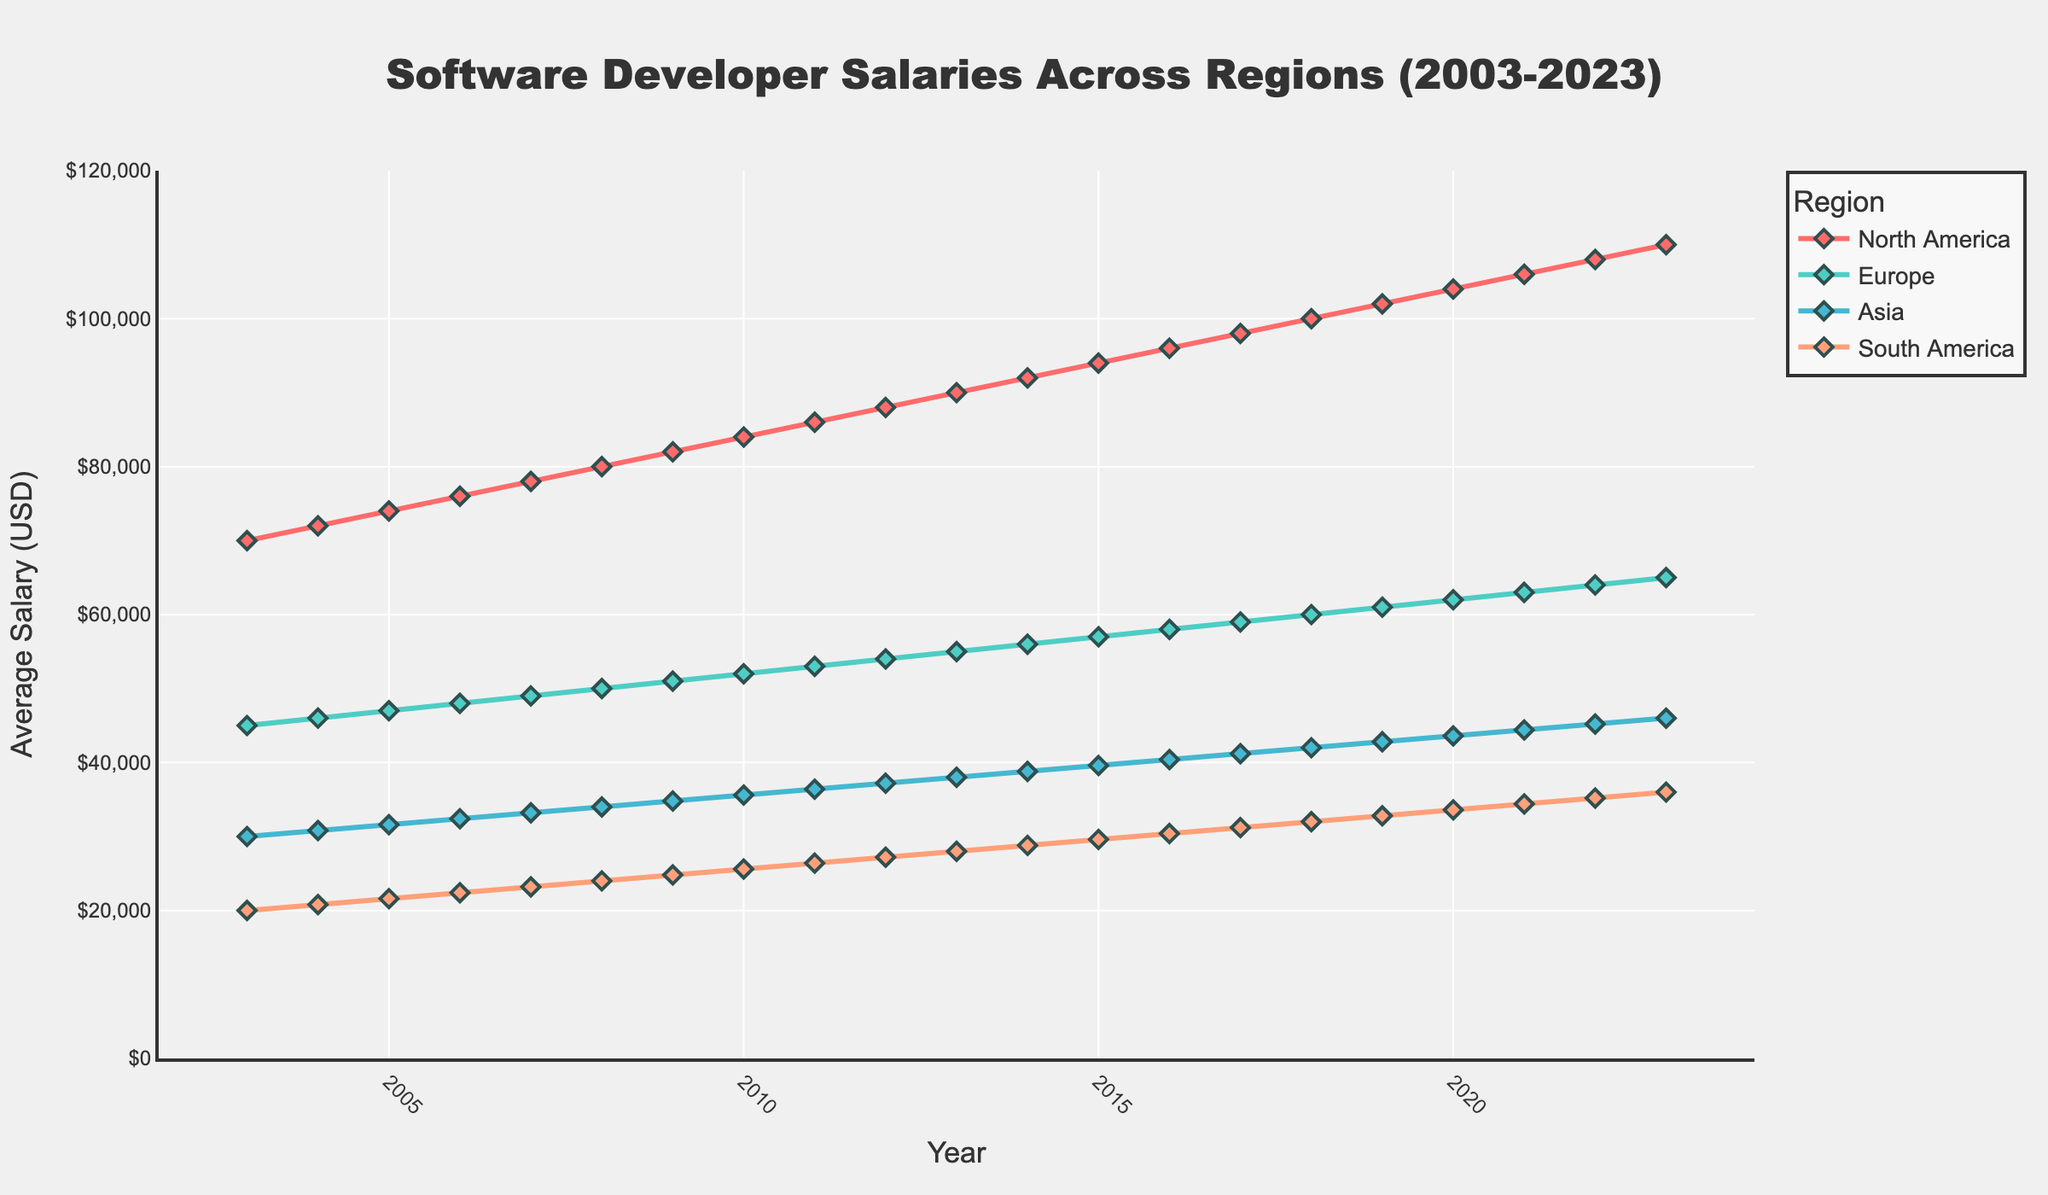What is the title of the plot? The title of the plot is displayed at the top and describes the overall content of the graph. It reads "Software Developer Salaries Across Regions (2003-2023)".
Answer: Software Developer Salaries Across Regions (2003-2023) How many regions are compared in the plot? There are four different colored lines in the plot, each representing a region. These regions are listed in the legend: North America, Europe, Asia, and South America.
Answer: 4 Which region had the highest average salary in 2023? By observing the lines' endpoints at the year 2023 on the x-axis, the North America region has the highest endpoint on the y-axis (average salary).
Answer: North America What was the average salary of software developers in Europe in 2015? By locating the year 2015 on the x-axis and following it vertically to the Europe region's line (noted by its color and legend), the approximate y-axis value is around 57,000 USD.
Answer: 57,000 USD Which region had the most significant increase in average salary over the 20 years? By comparing the starting and ending points of each region's line, North America's line shows the largest vertical increase from roughly 70,000 USD in 2003 to 110,000 USD in 2023.
Answer: North America What is the average salary difference between North America and South America in 2023? By locating the year 2023 on the x-axis for both regions and noting their y-axis values, North America is around 110,000 USD, and South America is around 36,000 USD. The difference is 110,000 - 36,000.
Answer: 74,000 USD How did the trend for average salaries in Asia compare to Europe between 2010 and 2020? Observing the lines for Asia and Europe between 2010 and 2020, Europe shows a steady increase, while Asia also shows an increase but at a slightly more gradual slope. Both regions' lines rise, but Europe's slope is a bit steeper.
Answer: Both increasing, but Europe's increase is steeper By how much did the average salary in South America increase from 2003 to 2023? Locate the points for South America at 2003 and 2023 on the x-axis, and compare their y-axis values. 2003 is around 20,000 USD and 2023 is around 36,000 USD. The difference is 36,000 - 20,000.
Answer: 16,000 USD What year did Europe’s average salary reach 50,000 USD? Follow the Europe line to find where it crosses the 50,000 USD mark on the y-axis. This point intersects the year 2008 on the x-axis.
Answer: 2008 Which region had the lowest average salary for the entire period? By comparing the height of the lines over the entire period, South America consistently has the lowest values on the y-axis compared to other regions.
Answer: South America 